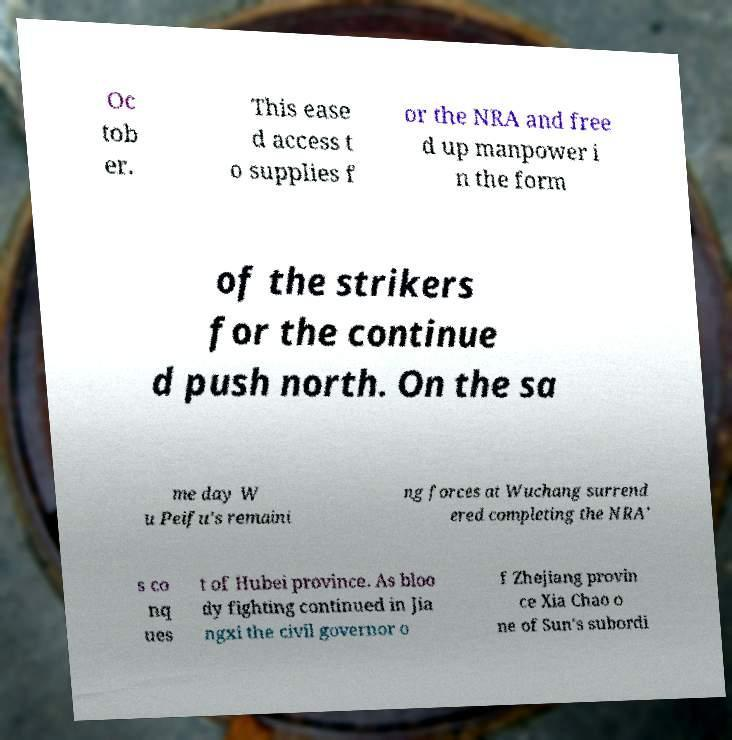Can you read and provide the text displayed in the image?This photo seems to have some interesting text. Can you extract and type it out for me? Oc tob er. This ease d access t o supplies f or the NRA and free d up manpower i n the form of the strikers for the continue d push north. On the sa me day W u Peifu's remaini ng forces at Wuchang surrend ered completing the NRA' s co nq ues t of Hubei province. As bloo dy fighting continued in Jia ngxi the civil governor o f Zhejiang provin ce Xia Chao o ne of Sun's subordi 